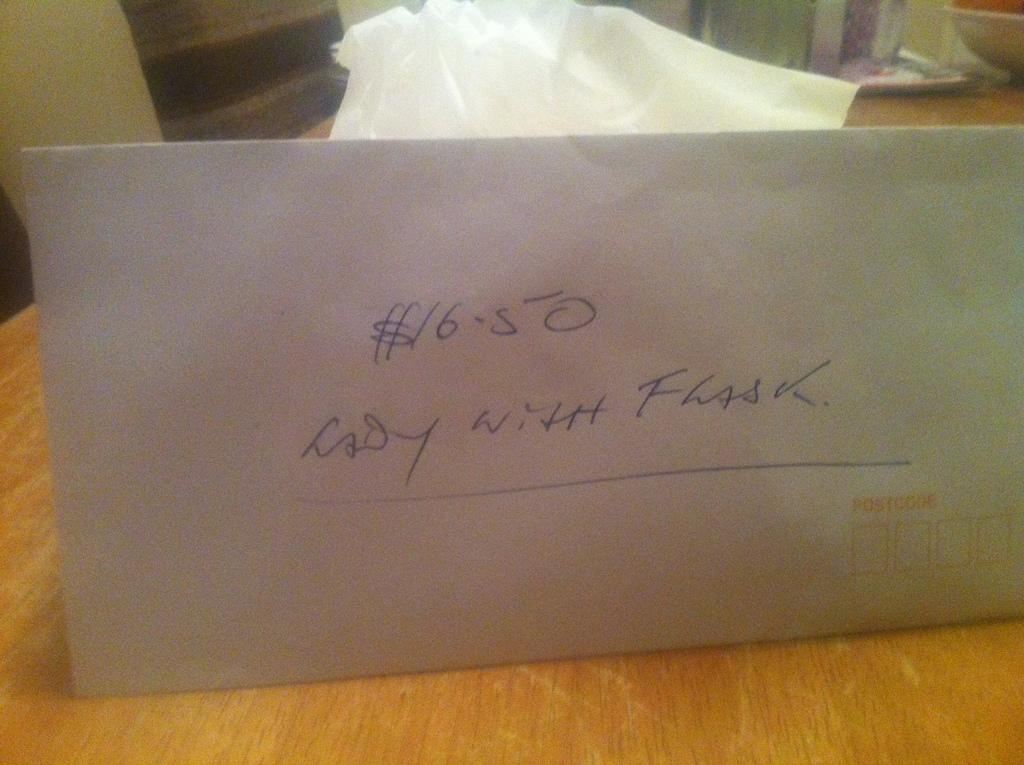<image>
Write a terse but informative summary of the picture. A white envelope with $16.50 lady with flask written on it. 